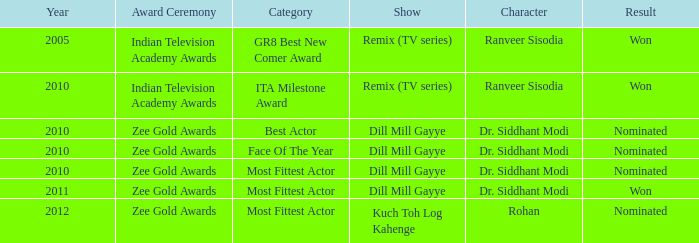Which show was nominated for the ITA Milestone Award at the Indian Television Academy Awards? Remix (TV series). 